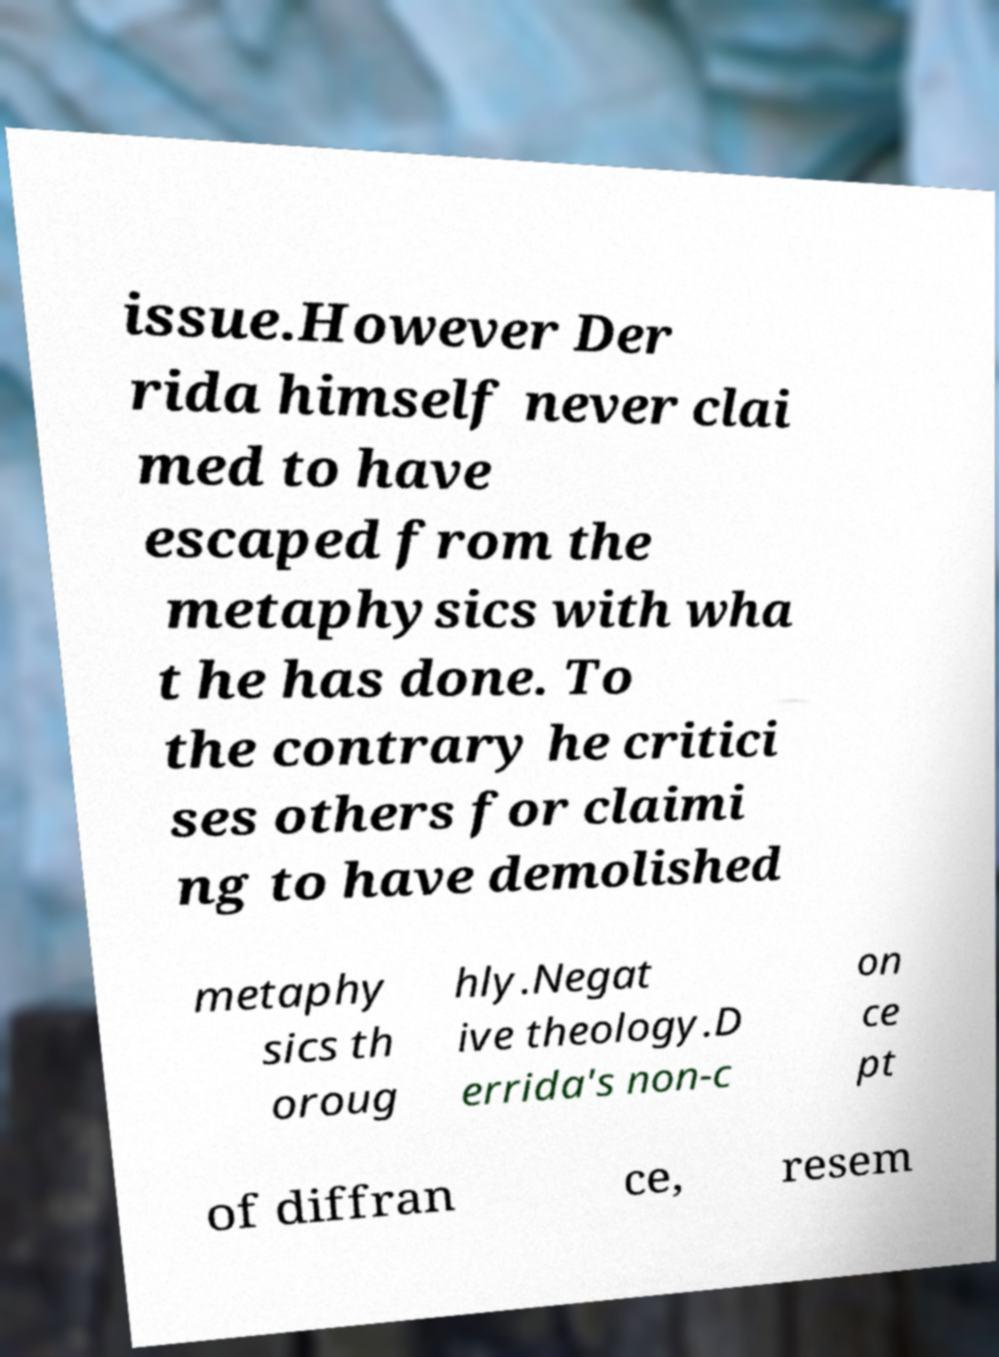Can you accurately transcribe the text from the provided image for me? issue.However Der rida himself never clai med to have escaped from the metaphysics with wha t he has done. To the contrary he critici ses others for claimi ng to have demolished metaphy sics th oroug hly.Negat ive theology.D errida's non-c on ce pt of diffran ce, resem 